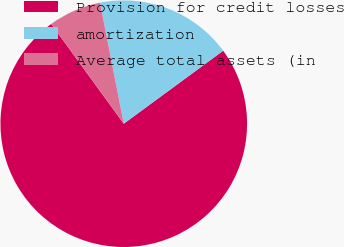Convert chart. <chart><loc_0><loc_0><loc_500><loc_500><pie_chart><fcel>Provision for credit losses<fcel>amortization<fcel>Average total assets (in<nl><fcel>75.08%<fcel>18.01%<fcel>6.92%<nl></chart> 